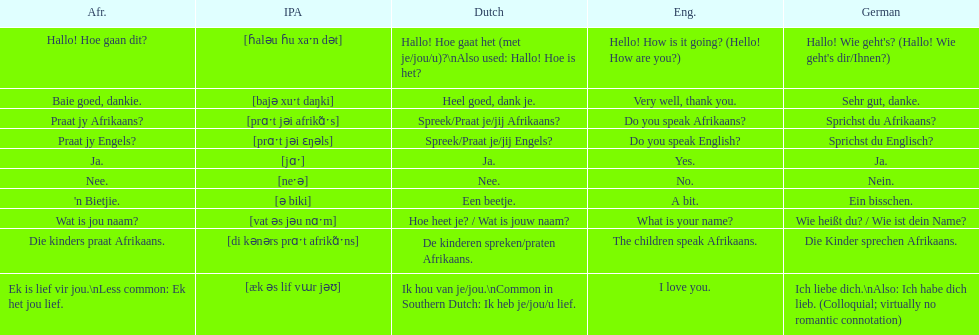Translate the following into german: die kinders praat afrikaans. Die Kinder sprechen Afrikaans. 